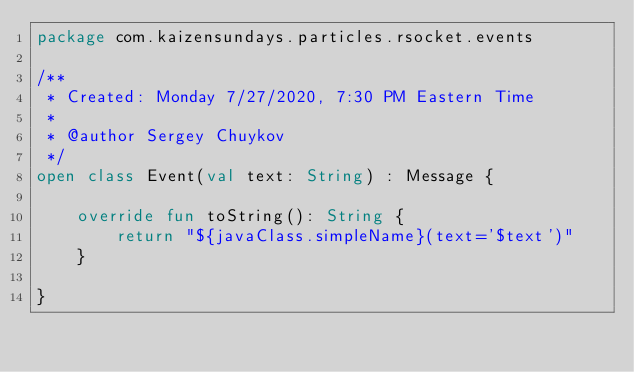Convert code to text. <code><loc_0><loc_0><loc_500><loc_500><_Kotlin_>package com.kaizensundays.particles.rsocket.events

/**
 * Created: Monday 7/27/2020, 7:30 PM Eastern Time
 *
 * @author Sergey Chuykov
 */
open class Event(val text: String) : Message {

    override fun toString(): String {
        return "${javaClass.simpleName}(text='$text')"
    }

}</code> 